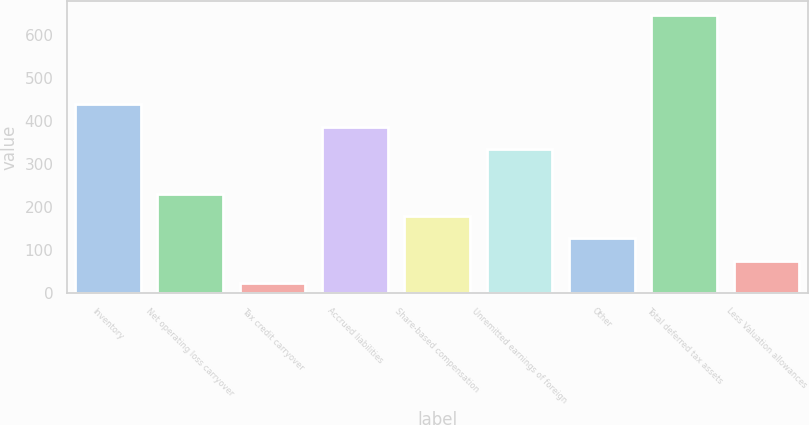Convert chart to OTSL. <chart><loc_0><loc_0><loc_500><loc_500><bar_chart><fcel>Inventory<fcel>Net operating loss carryover<fcel>Tax credit carryover<fcel>Accrued liabilities<fcel>Share-based compensation<fcel>Unremitted earnings of foreign<fcel>Other<fcel>Total deferred tax assets<fcel>Less Valuation allowances<nl><fcel>439.22<fcel>231.46<fcel>23.7<fcel>387.28<fcel>179.52<fcel>335.34<fcel>127.58<fcel>646.98<fcel>75.64<nl></chart> 